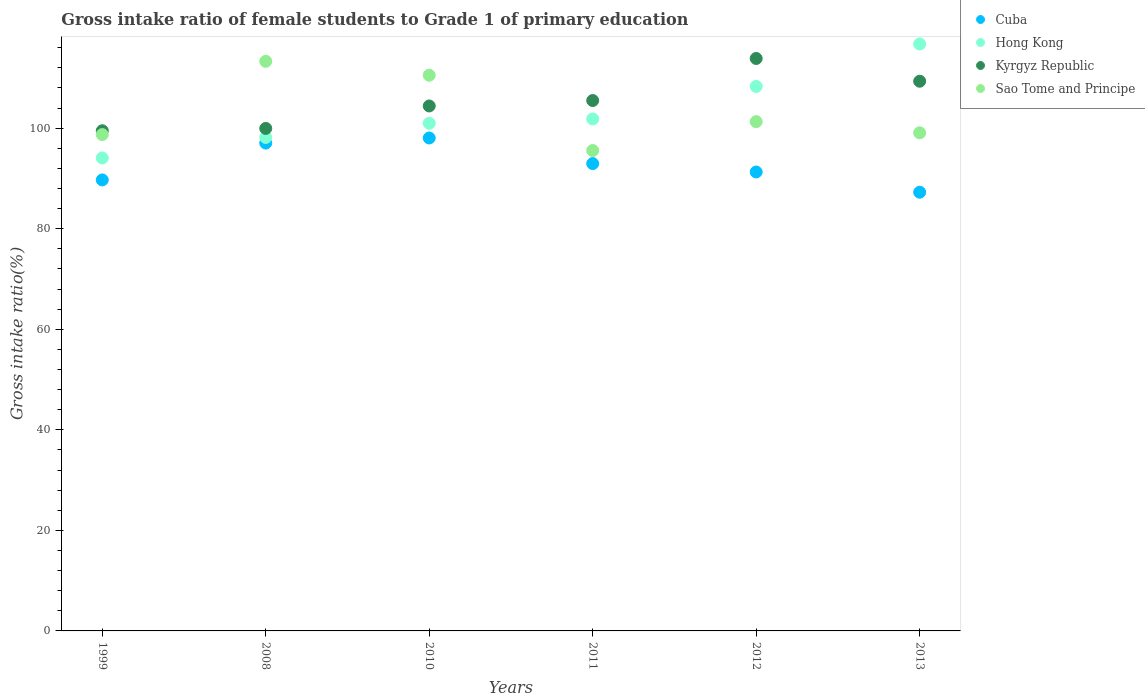How many different coloured dotlines are there?
Make the answer very short. 4. What is the gross intake ratio in Hong Kong in 2010?
Your answer should be very brief. 100.97. Across all years, what is the maximum gross intake ratio in Kyrgyz Republic?
Your response must be concise. 113.86. Across all years, what is the minimum gross intake ratio in Sao Tome and Principe?
Ensure brevity in your answer.  95.55. In which year was the gross intake ratio in Cuba maximum?
Your answer should be very brief. 2010. What is the total gross intake ratio in Kyrgyz Republic in the graph?
Your response must be concise. 632.54. What is the difference between the gross intake ratio in Kyrgyz Republic in 2010 and that in 2011?
Your response must be concise. -1.08. What is the difference between the gross intake ratio in Hong Kong in 2013 and the gross intake ratio in Kyrgyz Republic in 2008?
Offer a very short reply. 16.8. What is the average gross intake ratio in Sao Tome and Principe per year?
Make the answer very short. 103.08. In the year 1999, what is the difference between the gross intake ratio in Hong Kong and gross intake ratio in Sao Tome and Principe?
Make the answer very short. -4.66. In how many years, is the gross intake ratio in Cuba greater than 44 %?
Provide a short and direct response. 6. What is the ratio of the gross intake ratio in Hong Kong in 1999 to that in 2010?
Offer a terse response. 0.93. Is the difference between the gross intake ratio in Hong Kong in 2011 and 2012 greater than the difference between the gross intake ratio in Sao Tome and Principe in 2011 and 2012?
Your answer should be very brief. No. What is the difference between the highest and the second highest gross intake ratio in Sao Tome and Principe?
Provide a short and direct response. 2.77. What is the difference between the highest and the lowest gross intake ratio in Sao Tome and Principe?
Give a very brief answer. 17.74. Is the sum of the gross intake ratio in Hong Kong in 1999 and 2008 greater than the maximum gross intake ratio in Sao Tome and Principe across all years?
Make the answer very short. Yes. Does the gross intake ratio in Hong Kong monotonically increase over the years?
Ensure brevity in your answer.  Yes. How many dotlines are there?
Make the answer very short. 4. Are the values on the major ticks of Y-axis written in scientific E-notation?
Make the answer very short. No. Does the graph contain grids?
Offer a very short reply. No. How are the legend labels stacked?
Your answer should be very brief. Vertical. What is the title of the graph?
Your response must be concise. Gross intake ratio of female students to Grade 1 of primary education. What is the label or title of the X-axis?
Keep it short and to the point. Years. What is the label or title of the Y-axis?
Your response must be concise. Gross intake ratio(%). What is the Gross intake ratio(%) of Cuba in 1999?
Ensure brevity in your answer.  89.7. What is the Gross intake ratio(%) in Hong Kong in 1999?
Offer a terse response. 94.07. What is the Gross intake ratio(%) of Kyrgyz Republic in 1999?
Give a very brief answer. 99.49. What is the Gross intake ratio(%) of Sao Tome and Principe in 1999?
Make the answer very short. 98.73. What is the Gross intake ratio(%) of Cuba in 2008?
Provide a succinct answer. 97.04. What is the Gross intake ratio(%) in Hong Kong in 2008?
Give a very brief answer. 98.15. What is the Gross intake ratio(%) of Kyrgyz Republic in 2008?
Offer a terse response. 99.95. What is the Gross intake ratio(%) of Sao Tome and Principe in 2008?
Offer a very short reply. 113.29. What is the Gross intake ratio(%) in Cuba in 2010?
Your answer should be compact. 98.05. What is the Gross intake ratio(%) in Hong Kong in 2010?
Your answer should be very brief. 100.97. What is the Gross intake ratio(%) in Kyrgyz Republic in 2010?
Make the answer very short. 104.41. What is the Gross intake ratio(%) in Sao Tome and Principe in 2010?
Your response must be concise. 110.52. What is the Gross intake ratio(%) of Cuba in 2011?
Offer a very short reply. 92.95. What is the Gross intake ratio(%) of Hong Kong in 2011?
Offer a very short reply. 101.83. What is the Gross intake ratio(%) in Kyrgyz Republic in 2011?
Offer a terse response. 105.5. What is the Gross intake ratio(%) of Sao Tome and Principe in 2011?
Your response must be concise. 95.55. What is the Gross intake ratio(%) in Cuba in 2012?
Ensure brevity in your answer.  91.28. What is the Gross intake ratio(%) in Hong Kong in 2012?
Your answer should be very brief. 108.3. What is the Gross intake ratio(%) in Kyrgyz Republic in 2012?
Make the answer very short. 113.86. What is the Gross intake ratio(%) in Sao Tome and Principe in 2012?
Your response must be concise. 101.3. What is the Gross intake ratio(%) in Cuba in 2013?
Provide a short and direct response. 87.26. What is the Gross intake ratio(%) in Hong Kong in 2013?
Keep it short and to the point. 116.74. What is the Gross intake ratio(%) of Kyrgyz Republic in 2013?
Your answer should be very brief. 109.34. What is the Gross intake ratio(%) of Sao Tome and Principe in 2013?
Your answer should be compact. 99.08. Across all years, what is the maximum Gross intake ratio(%) in Cuba?
Your answer should be very brief. 98.05. Across all years, what is the maximum Gross intake ratio(%) of Hong Kong?
Offer a very short reply. 116.74. Across all years, what is the maximum Gross intake ratio(%) of Kyrgyz Republic?
Ensure brevity in your answer.  113.86. Across all years, what is the maximum Gross intake ratio(%) of Sao Tome and Principe?
Your answer should be compact. 113.29. Across all years, what is the minimum Gross intake ratio(%) in Cuba?
Your answer should be very brief. 87.26. Across all years, what is the minimum Gross intake ratio(%) of Hong Kong?
Make the answer very short. 94.07. Across all years, what is the minimum Gross intake ratio(%) of Kyrgyz Republic?
Keep it short and to the point. 99.49. Across all years, what is the minimum Gross intake ratio(%) in Sao Tome and Principe?
Ensure brevity in your answer.  95.55. What is the total Gross intake ratio(%) of Cuba in the graph?
Keep it short and to the point. 556.29. What is the total Gross intake ratio(%) in Hong Kong in the graph?
Your response must be concise. 620.07. What is the total Gross intake ratio(%) in Kyrgyz Republic in the graph?
Give a very brief answer. 632.54. What is the total Gross intake ratio(%) in Sao Tome and Principe in the graph?
Your response must be concise. 618.48. What is the difference between the Gross intake ratio(%) in Cuba in 1999 and that in 2008?
Make the answer very short. -7.33. What is the difference between the Gross intake ratio(%) of Hong Kong in 1999 and that in 2008?
Give a very brief answer. -4.08. What is the difference between the Gross intake ratio(%) of Kyrgyz Republic in 1999 and that in 2008?
Offer a terse response. -0.46. What is the difference between the Gross intake ratio(%) of Sao Tome and Principe in 1999 and that in 2008?
Offer a very short reply. -14.57. What is the difference between the Gross intake ratio(%) in Cuba in 1999 and that in 2010?
Provide a short and direct response. -8.35. What is the difference between the Gross intake ratio(%) in Hong Kong in 1999 and that in 2010?
Offer a terse response. -6.9. What is the difference between the Gross intake ratio(%) in Kyrgyz Republic in 1999 and that in 2010?
Give a very brief answer. -4.93. What is the difference between the Gross intake ratio(%) of Sao Tome and Principe in 1999 and that in 2010?
Your response must be concise. -11.8. What is the difference between the Gross intake ratio(%) in Cuba in 1999 and that in 2011?
Give a very brief answer. -3.25. What is the difference between the Gross intake ratio(%) in Hong Kong in 1999 and that in 2011?
Provide a short and direct response. -7.76. What is the difference between the Gross intake ratio(%) of Kyrgyz Republic in 1999 and that in 2011?
Provide a succinct answer. -6.01. What is the difference between the Gross intake ratio(%) of Sao Tome and Principe in 1999 and that in 2011?
Provide a short and direct response. 3.17. What is the difference between the Gross intake ratio(%) in Cuba in 1999 and that in 2012?
Offer a very short reply. -1.58. What is the difference between the Gross intake ratio(%) in Hong Kong in 1999 and that in 2012?
Your answer should be very brief. -14.23. What is the difference between the Gross intake ratio(%) of Kyrgyz Republic in 1999 and that in 2012?
Provide a short and direct response. -14.38. What is the difference between the Gross intake ratio(%) in Sao Tome and Principe in 1999 and that in 2012?
Keep it short and to the point. -2.57. What is the difference between the Gross intake ratio(%) of Cuba in 1999 and that in 2013?
Make the answer very short. 2.44. What is the difference between the Gross intake ratio(%) in Hong Kong in 1999 and that in 2013?
Keep it short and to the point. -22.67. What is the difference between the Gross intake ratio(%) in Kyrgyz Republic in 1999 and that in 2013?
Keep it short and to the point. -9.85. What is the difference between the Gross intake ratio(%) in Sao Tome and Principe in 1999 and that in 2013?
Provide a short and direct response. -0.35. What is the difference between the Gross intake ratio(%) of Cuba in 2008 and that in 2010?
Provide a succinct answer. -1.01. What is the difference between the Gross intake ratio(%) in Hong Kong in 2008 and that in 2010?
Your response must be concise. -2.82. What is the difference between the Gross intake ratio(%) in Kyrgyz Republic in 2008 and that in 2010?
Offer a terse response. -4.47. What is the difference between the Gross intake ratio(%) of Sao Tome and Principe in 2008 and that in 2010?
Provide a short and direct response. 2.77. What is the difference between the Gross intake ratio(%) in Cuba in 2008 and that in 2011?
Offer a very short reply. 4.08. What is the difference between the Gross intake ratio(%) of Hong Kong in 2008 and that in 2011?
Make the answer very short. -3.68. What is the difference between the Gross intake ratio(%) of Kyrgyz Republic in 2008 and that in 2011?
Ensure brevity in your answer.  -5.55. What is the difference between the Gross intake ratio(%) in Sao Tome and Principe in 2008 and that in 2011?
Ensure brevity in your answer.  17.74. What is the difference between the Gross intake ratio(%) in Cuba in 2008 and that in 2012?
Keep it short and to the point. 5.75. What is the difference between the Gross intake ratio(%) of Hong Kong in 2008 and that in 2012?
Offer a very short reply. -10.15. What is the difference between the Gross intake ratio(%) in Kyrgyz Republic in 2008 and that in 2012?
Your response must be concise. -13.91. What is the difference between the Gross intake ratio(%) in Sao Tome and Principe in 2008 and that in 2012?
Keep it short and to the point. 12. What is the difference between the Gross intake ratio(%) of Cuba in 2008 and that in 2013?
Your response must be concise. 9.78. What is the difference between the Gross intake ratio(%) of Hong Kong in 2008 and that in 2013?
Your answer should be very brief. -18.59. What is the difference between the Gross intake ratio(%) of Kyrgyz Republic in 2008 and that in 2013?
Keep it short and to the point. -9.39. What is the difference between the Gross intake ratio(%) of Sao Tome and Principe in 2008 and that in 2013?
Offer a terse response. 14.22. What is the difference between the Gross intake ratio(%) in Cuba in 2010 and that in 2011?
Make the answer very short. 5.1. What is the difference between the Gross intake ratio(%) of Hong Kong in 2010 and that in 2011?
Provide a short and direct response. -0.87. What is the difference between the Gross intake ratio(%) of Kyrgyz Republic in 2010 and that in 2011?
Your answer should be compact. -1.08. What is the difference between the Gross intake ratio(%) of Sao Tome and Principe in 2010 and that in 2011?
Your response must be concise. 14.97. What is the difference between the Gross intake ratio(%) in Cuba in 2010 and that in 2012?
Your answer should be very brief. 6.77. What is the difference between the Gross intake ratio(%) of Hong Kong in 2010 and that in 2012?
Your answer should be very brief. -7.34. What is the difference between the Gross intake ratio(%) in Kyrgyz Republic in 2010 and that in 2012?
Make the answer very short. -9.45. What is the difference between the Gross intake ratio(%) of Sao Tome and Principe in 2010 and that in 2012?
Provide a short and direct response. 9.23. What is the difference between the Gross intake ratio(%) of Cuba in 2010 and that in 2013?
Keep it short and to the point. 10.79. What is the difference between the Gross intake ratio(%) of Hong Kong in 2010 and that in 2013?
Your response must be concise. -15.78. What is the difference between the Gross intake ratio(%) of Kyrgyz Republic in 2010 and that in 2013?
Keep it short and to the point. -4.92. What is the difference between the Gross intake ratio(%) of Sao Tome and Principe in 2010 and that in 2013?
Your answer should be compact. 11.44. What is the difference between the Gross intake ratio(%) of Cuba in 2011 and that in 2012?
Your answer should be compact. 1.67. What is the difference between the Gross intake ratio(%) in Hong Kong in 2011 and that in 2012?
Offer a terse response. -6.47. What is the difference between the Gross intake ratio(%) in Kyrgyz Republic in 2011 and that in 2012?
Offer a terse response. -8.36. What is the difference between the Gross intake ratio(%) in Sao Tome and Principe in 2011 and that in 2012?
Your answer should be very brief. -5.74. What is the difference between the Gross intake ratio(%) in Cuba in 2011 and that in 2013?
Your answer should be compact. 5.7. What is the difference between the Gross intake ratio(%) in Hong Kong in 2011 and that in 2013?
Your answer should be very brief. -14.91. What is the difference between the Gross intake ratio(%) in Kyrgyz Republic in 2011 and that in 2013?
Keep it short and to the point. -3.84. What is the difference between the Gross intake ratio(%) of Sao Tome and Principe in 2011 and that in 2013?
Provide a short and direct response. -3.53. What is the difference between the Gross intake ratio(%) of Cuba in 2012 and that in 2013?
Provide a short and direct response. 4.03. What is the difference between the Gross intake ratio(%) in Hong Kong in 2012 and that in 2013?
Ensure brevity in your answer.  -8.44. What is the difference between the Gross intake ratio(%) of Kyrgyz Republic in 2012 and that in 2013?
Offer a very short reply. 4.52. What is the difference between the Gross intake ratio(%) in Sao Tome and Principe in 2012 and that in 2013?
Provide a succinct answer. 2.22. What is the difference between the Gross intake ratio(%) of Cuba in 1999 and the Gross intake ratio(%) of Hong Kong in 2008?
Provide a succinct answer. -8.45. What is the difference between the Gross intake ratio(%) of Cuba in 1999 and the Gross intake ratio(%) of Kyrgyz Republic in 2008?
Your answer should be very brief. -10.24. What is the difference between the Gross intake ratio(%) of Cuba in 1999 and the Gross intake ratio(%) of Sao Tome and Principe in 2008?
Provide a succinct answer. -23.59. What is the difference between the Gross intake ratio(%) of Hong Kong in 1999 and the Gross intake ratio(%) of Kyrgyz Republic in 2008?
Your response must be concise. -5.88. What is the difference between the Gross intake ratio(%) in Hong Kong in 1999 and the Gross intake ratio(%) in Sao Tome and Principe in 2008?
Your answer should be very brief. -19.22. What is the difference between the Gross intake ratio(%) in Kyrgyz Republic in 1999 and the Gross intake ratio(%) in Sao Tome and Principe in 2008?
Keep it short and to the point. -13.81. What is the difference between the Gross intake ratio(%) in Cuba in 1999 and the Gross intake ratio(%) in Hong Kong in 2010?
Your response must be concise. -11.26. What is the difference between the Gross intake ratio(%) of Cuba in 1999 and the Gross intake ratio(%) of Kyrgyz Republic in 2010?
Provide a short and direct response. -14.71. What is the difference between the Gross intake ratio(%) of Cuba in 1999 and the Gross intake ratio(%) of Sao Tome and Principe in 2010?
Give a very brief answer. -20.82. What is the difference between the Gross intake ratio(%) of Hong Kong in 1999 and the Gross intake ratio(%) of Kyrgyz Republic in 2010?
Offer a terse response. -10.34. What is the difference between the Gross intake ratio(%) of Hong Kong in 1999 and the Gross intake ratio(%) of Sao Tome and Principe in 2010?
Give a very brief answer. -16.45. What is the difference between the Gross intake ratio(%) in Kyrgyz Republic in 1999 and the Gross intake ratio(%) in Sao Tome and Principe in 2010?
Offer a terse response. -11.04. What is the difference between the Gross intake ratio(%) in Cuba in 1999 and the Gross intake ratio(%) in Hong Kong in 2011?
Offer a very short reply. -12.13. What is the difference between the Gross intake ratio(%) of Cuba in 1999 and the Gross intake ratio(%) of Kyrgyz Republic in 2011?
Provide a succinct answer. -15.79. What is the difference between the Gross intake ratio(%) in Cuba in 1999 and the Gross intake ratio(%) in Sao Tome and Principe in 2011?
Your response must be concise. -5.85. What is the difference between the Gross intake ratio(%) in Hong Kong in 1999 and the Gross intake ratio(%) in Kyrgyz Republic in 2011?
Your answer should be compact. -11.43. What is the difference between the Gross intake ratio(%) of Hong Kong in 1999 and the Gross intake ratio(%) of Sao Tome and Principe in 2011?
Your answer should be very brief. -1.48. What is the difference between the Gross intake ratio(%) in Kyrgyz Republic in 1999 and the Gross intake ratio(%) in Sao Tome and Principe in 2011?
Keep it short and to the point. 3.93. What is the difference between the Gross intake ratio(%) of Cuba in 1999 and the Gross intake ratio(%) of Hong Kong in 2012?
Your response must be concise. -18.6. What is the difference between the Gross intake ratio(%) in Cuba in 1999 and the Gross intake ratio(%) in Kyrgyz Republic in 2012?
Make the answer very short. -24.16. What is the difference between the Gross intake ratio(%) of Cuba in 1999 and the Gross intake ratio(%) of Sao Tome and Principe in 2012?
Ensure brevity in your answer.  -11.59. What is the difference between the Gross intake ratio(%) of Hong Kong in 1999 and the Gross intake ratio(%) of Kyrgyz Republic in 2012?
Your answer should be very brief. -19.79. What is the difference between the Gross intake ratio(%) in Hong Kong in 1999 and the Gross intake ratio(%) in Sao Tome and Principe in 2012?
Your answer should be very brief. -7.23. What is the difference between the Gross intake ratio(%) of Kyrgyz Republic in 1999 and the Gross intake ratio(%) of Sao Tome and Principe in 2012?
Your answer should be very brief. -1.81. What is the difference between the Gross intake ratio(%) of Cuba in 1999 and the Gross intake ratio(%) of Hong Kong in 2013?
Offer a terse response. -27.04. What is the difference between the Gross intake ratio(%) in Cuba in 1999 and the Gross intake ratio(%) in Kyrgyz Republic in 2013?
Make the answer very short. -19.63. What is the difference between the Gross intake ratio(%) in Cuba in 1999 and the Gross intake ratio(%) in Sao Tome and Principe in 2013?
Ensure brevity in your answer.  -9.38. What is the difference between the Gross intake ratio(%) in Hong Kong in 1999 and the Gross intake ratio(%) in Kyrgyz Republic in 2013?
Make the answer very short. -15.27. What is the difference between the Gross intake ratio(%) in Hong Kong in 1999 and the Gross intake ratio(%) in Sao Tome and Principe in 2013?
Make the answer very short. -5.01. What is the difference between the Gross intake ratio(%) of Kyrgyz Republic in 1999 and the Gross intake ratio(%) of Sao Tome and Principe in 2013?
Provide a succinct answer. 0.41. What is the difference between the Gross intake ratio(%) of Cuba in 2008 and the Gross intake ratio(%) of Hong Kong in 2010?
Provide a short and direct response. -3.93. What is the difference between the Gross intake ratio(%) of Cuba in 2008 and the Gross intake ratio(%) of Kyrgyz Republic in 2010?
Your response must be concise. -7.38. What is the difference between the Gross intake ratio(%) in Cuba in 2008 and the Gross intake ratio(%) in Sao Tome and Principe in 2010?
Ensure brevity in your answer.  -13.49. What is the difference between the Gross intake ratio(%) of Hong Kong in 2008 and the Gross intake ratio(%) of Kyrgyz Republic in 2010?
Offer a terse response. -6.26. What is the difference between the Gross intake ratio(%) in Hong Kong in 2008 and the Gross intake ratio(%) in Sao Tome and Principe in 2010?
Make the answer very short. -12.37. What is the difference between the Gross intake ratio(%) in Kyrgyz Republic in 2008 and the Gross intake ratio(%) in Sao Tome and Principe in 2010?
Offer a terse response. -10.58. What is the difference between the Gross intake ratio(%) of Cuba in 2008 and the Gross intake ratio(%) of Hong Kong in 2011?
Your answer should be very brief. -4.8. What is the difference between the Gross intake ratio(%) in Cuba in 2008 and the Gross intake ratio(%) in Kyrgyz Republic in 2011?
Your answer should be compact. -8.46. What is the difference between the Gross intake ratio(%) in Cuba in 2008 and the Gross intake ratio(%) in Sao Tome and Principe in 2011?
Provide a succinct answer. 1.48. What is the difference between the Gross intake ratio(%) in Hong Kong in 2008 and the Gross intake ratio(%) in Kyrgyz Republic in 2011?
Your answer should be very brief. -7.35. What is the difference between the Gross intake ratio(%) in Hong Kong in 2008 and the Gross intake ratio(%) in Sao Tome and Principe in 2011?
Make the answer very short. 2.6. What is the difference between the Gross intake ratio(%) of Kyrgyz Republic in 2008 and the Gross intake ratio(%) of Sao Tome and Principe in 2011?
Your answer should be very brief. 4.39. What is the difference between the Gross intake ratio(%) of Cuba in 2008 and the Gross intake ratio(%) of Hong Kong in 2012?
Your answer should be very brief. -11.27. What is the difference between the Gross intake ratio(%) in Cuba in 2008 and the Gross intake ratio(%) in Kyrgyz Republic in 2012?
Make the answer very short. -16.83. What is the difference between the Gross intake ratio(%) of Cuba in 2008 and the Gross intake ratio(%) of Sao Tome and Principe in 2012?
Ensure brevity in your answer.  -4.26. What is the difference between the Gross intake ratio(%) of Hong Kong in 2008 and the Gross intake ratio(%) of Kyrgyz Republic in 2012?
Ensure brevity in your answer.  -15.71. What is the difference between the Gross intake ratio(%) of Hong Kong in 2008 and the Gross intake ratio(%) of Sao Tome and Principe in 2012?
Offer a terse response. -3.15. What is the difference between the Gross intake ratio(%) of Kyrgyz Republic in 2008 and the Gross intake ratio(%) of Sao Tome and Principe in 2012?
Provide a short and direct response. -1.35. What is the difference between the Gross intake ratio(%) of Cuba in 2008 and the Gross intake ratio(%) of Hong Kong in 2013?
Your answer should be very brief. -19.71. What is the difference between the Gross intake ratio(%) in Cuba in 2008 and the Gross intake ratio(%) in Kyrgyz Republic in 2013?
Offer a terse response. -12.3. What is the difference between the Gross intake ratio(%) of Cuba in 2008 and the Gross intake ratio(%) of Sao Tome and Principe in 2013?
Your response must be concise. -2.04. What is the difference between the Gross intake ratio(%) of Hong Kong in 2008 and the Gross intake ratio(%) of Kyrgyz Republic in 2013?
Give a very brief answer. -11.19. What is the difference between the Gross intake ratio(%) of Hong Kong in 2008 and the Gross intake ratio(%) of Sao Tome and Principe in 2013?
Offer a very short reply. -0.93. What is the difference between the Gross intake ratio(%) of Kyrgyz Republic in 2008 and the Gross intake ratio(%) of Sao Tome and Principe in 2013?
Provide a succinct answer. 0.87. What is the difference between the Gross intake ratio(%) in Cuba in 2010 and the Gross intake ratio(%) in Hong Kong in 2011?
Offer a very short reply. -3.78. What is the difference between the Gross intake ratio(%) of Cuba in 2010 and the Gross intake ratio(%) of Kyrgyz Republic in 2011?
Keep it short and to the point. -7.45. What is the difference between the Gross intake ratio(%) of Cuba in 2010 and the Gross intake ratio(%) of Sao Tome and Principe in 2011?
Provide a short and direct response. 2.5. What is the difference between the Gross intake ratio(%) in Hong Kong in 2010 and the Gross intake ratio(%) in Kyrgyz Republic in 2011?
Give a very brief answer. -4.53. What is the difference between the Gross intake ratio(%) in Hong Kong in 2010 and the Gross intake ratio(%) in Sao Tome and Principe in 2011?
Keep it short and to the point. 5.41. What is the difference between the Gross intake ratio(%) of Kyrgyz Republic in 2010 and the Gross intake ratio(%) of Sao Tome and Principe in 2011?
Your answer should be very brief. 8.86. What is the difference between the Gross intake ratio(%) in Cuba in 2010 and the Gross intake ratio(%) in Hong Kong in 2012?
Make the answer very short. -10.25. What is the difference between the Gross intake ratio(%) of Cuba in 2010 and the Gross intake ratio(%) of Kyrgyz Republic in 2012?
Keep it short and to the point. -15.81. What is the difference between the Gross intake ratio(%) in Cuba in 2010 and the Gross intake ratio(%) in Sao Tome and Principe in 2012?
Provide a short and direct response. -3.25. What is the difference between the Gross intake ratio(%) in Hong Kong in 2010 and the Gross intake ratio(%) in Kyrgyz Republic in 2012?
Keep it short and to the point. -12.89. What is the difference between the Gross intake ratio(%) in Hong Kong in 2010 and the Gross intake ratio(%) in Sao Tome and Principe in 2012?
Provide a short and direct response. -0.33. What is the difference between the Gross intake ratio(%) of Kyrgyz Republic in 2010 and the Gross intake ratio(%) of Sao Tome and Principe in 2012?
Provide a succinct answer. 3.12. What is the difference between the Gross intake ratio(%) in Cuba in 2010 and the Gross intake ratio(%) in Hong Kong in 2013?
Give a very brief answer. -18.69. What is the difference between the Gross intake ratio(%) in Cuba in 2010 and the Gross intake ratio(%) in Kyrgyz Republic in 2013?
Your response must be concise. -11.29. What is the difference between the Gross intake ratio(%) in Cuba in 2010 and the Gross intake ratio(%) in Sao Tome and Principe in 2013?
Provide a succinct answer. -1.03. What is the difference between the Gross intake ratio(%) in Hong Kong in 2010 and the Gross intake ratio(%) in Kyrgyz Republic in 2013?
Offer a very short reply. -8.37. What is the difference between the Gross intake ratio(%) in Hong Kong in 2010 and the Gross intake ratio(%) in Sao Tome and Principe in 2013?
Keep it short and to the point. 1.89. What is the difference between the Gross intake ratio(%) of Kyrgyz Republic in 2010 and the Gross intake ratio(%) of Sao Tome and Principe in 2013?
Offer a terse response. 5.34. What is the difference between the Gross intake ratio(%) in Cuba in 2011 and the Gross intake ratio(%) in Hong Kong in 2012?
Provide a succinct answer. -15.35. What is the difference between the Gross intake ratio(%) of Cuba in 2011 and the Gross intake ratio(%) of Kyrgyz Republic in 2012?
Your response must be concise. -20.91. What is the difference between the Gross intake ratio(%) of Cuba in 2011 and the Gross intake ratio(%) of Sao Tome and Principe in 2012?
Give a very brief answer. -8.34. What is the difference between the Gross intake ratio(%) of Hong Kong in 2011 and the Gross intake ratio(%) of Kyrgyz Republic in 2012?
Offer a very short reply. -12.03. What is the difference between the Gross intake ratio(%) of Hong Kong in 2011 and the Gross intake ratio(%) of Sao Tome and Principe in 2012?
Your answer should be very brief. 0.54. What is the difference between the Gross intake ratio(%) in Kyrgyz Republic in 2011 and the Gross intake ratio(%) in Sao Tome and Principe in 2012?
Offer a terse response. 4.2. What is the difference between the Gross intake ratio(%) of Cuba in 2011 and the Gross intake ratio(%) of Hong Kong in 2013?
Offer a very short reply. -23.79. What is the difference between the Gross intake ratio(%) of Cuba in 2011 and the Gross intake ratio(%) of Kyrgyz Republic in 2013?
Provide a succinct answer. -16.38. What is the difference between the Gross intake ratio(%) in Cuba in 2011 and the Gross intake ratio(%) in Sao Tome and Principe in 2013?
Offer a very short reply. -6.12. What is the difference between the Gross intake ratio(%) of Hong Kong in 2011 and the Gross intake ratio(%) of Kyrgyz Republic in 2013?
Your answer should be compact. -7.5. What is the difference between the Gross intake ratio(%) in Hong Kong in 2011 and the Gross intake ratio(%) in Sao Tome and Principe in 2013?
Your answer should be compact. 2.76. What is the difference between the Gross intake ratio(%) of Kyrgyz Republic in 2011 and the Gross intake ratio(%) of Sao Tome and Principe in 2013?
Provide a short and direct response. 6.42. What is the difference between the Gross intake ratio(%) of Cuba in 2012 and the Gross intake ratio(%) of Hong Kong in 2013?
Provide a short and direct response. -25.46. What is the difference between the Gross intake ratio(%) in Cuba in 2012 and the Gross intake ratio(%) in Kyrgyz Republic in 2013?
Offer a terse response. -18.05. What is the difference between the Gross intake ratio(%) in Cuba in 2012 and the Gross intake ratio(%) in Sao Tome and Principe in 2013?
Keep it short and to the point. -7.79. What is the difference between the Gross intake ratio(%) in Hong Kong in 2012 and the Gross intake ratio(%) in Kyrgyz Republic in 2013?
Ensure brevity in your answer.  -1.03. What is the difference between the Gross intake ratio(%) of Hong Kong in 2012 and the Gross intake ratio(%) of Sao Tome and Principe in 2013?
Keep it short and to the point. 9.22. What is the difference between the Gross intake ratio(%) of Kyrgyz Republic in 2012 and the Gross intake ratio(%) of Sao Tome and Principe in 2013?
Your answer should be compact. 14.78. What is the average Gross intake ratio(%) in Cuba per year?
Your answer should be compact. 92.71. What is the average Gross intake ratio(%) of Hong Kong per year?
Offer a very short reply. 103.34. What is the average Gross intake ratio(%) of Kyrgyz Republic per year?
Provide a succinct answer. 105.42. What is the average Gross intake ratio(%) in Sao Tome and Principe per year?
Offer a very short reply. 103.08. In the year 1999, what is the difference between the Gross intake ratio(%) in Cuba and Gross intake ratio(%) in Hong Kong?
Your answer should be compact. -4.37. In the year 1999, what is the difference between the Gross intake ratio(%) of Cuba and Gross intake ratio(%) of Kyrgyz Republic?
Ensure brevity in your answer.  -9.78. In the year 1999, what is the difference between the Gross intake ratio(%) of Cuba and Gross intake ratio(%) of Sao Tome and Principe?
Your answer should be compact. -9.02. In the year 1999, what is the difference between the Gross intake ratio(%) of Hong Kong and Gross intake ratio(%) of Kyrgyz Republic?
Your answer should be compact. -5.42. In the year 1999, what is the difference between the Gross intake ratio(%) of Hong Kong and Gross intake ratio(%) of Sao Tome and Principe?
Your answer should be compact. -4.66. In the year 1999, what is the difference between the Gross intake ratio(%) in Kyrgyz Republic and Gross intake ratio(%) in Sao Tome and Principe?
Provide a short and direct response. 0.76. In the year 2008, what is the difference between the Gross intake ratio(%) of Cuba and Gross intake ratio(%) of Hong Kong?
Keep it short and to the point. -1.12. In the year 2008, what is the difference between the Gross intake ratio(%) in Cuba and Gross intake ratio(%) in Kyrgyz Republic?
Your answer should be very brief. -2.91. In the year 2008, what is the difference between the Gross intake ratio(%) in Cuba and Gross intake ratio(%) in Sao Tome and Principe?
Offer a terse response. -16.26. In the year 2008, what is the difference between the Gross intake ratio(%) of Hong Kong and Gross intake ratio(%) of Kyrgyz Republic?
Offer a very short reply. -1.8. In the year 2008, what is the difference between the Gross intake ratio(%) of Hong Kong and Gross intake ratio(%) of Sao Tome and Principe?
Your answer should be very brief. -15.14. In the year 2008, what is the difference between the Gross intake ratio(%) in Kyrgyz Republic and Gross intake ratio(%) in Sao Tome and Principe?
Offer a very short reply. -13.35. In the year 2010, what is the difference between the Gross intake ratio(%) in Cuba and Gross intake ratio(%) in Hong Kong?
Offer a terse response. -2.92. In the year 2010, what is the difference between the Gross intake ratio(%) in Cuba and Gross intake ratio(%) in Kyrgyz Republic?
Keep it short and to the point. -6.36. In the year 2010, what is the difference between the Gross intake ratio(%) of Cuba and Gross intake ratio(%) of Sao Tome and Principe?
Your response must be concise. -12.47. In the year 2010, what is the difference between the Gross intake ratio(%) in Hong Kong and Gross intake ratio(%) in Kyrgyz Republic?
Give a very brief answer. -3.45. In the year 2010, what is the difference between the Gross intake ratio(%) of Hong Kong and Gross intake ratio(%) of Sao Tome and Principe?
Provide a succinct answer. -9.56. In the year 2010, what is the difference between the Gross intake ratio(%) in Kyrgyz Republic and Gross intake ratio(%) in Sao Tome and Principe?
Make the answer very short. -6.11. In the year 2011, what is the difference between the Gross intake ratio(%) in Cuba and Gross intake ratio(%) in Hong Kong?
Your answer should be very brief. -8.88. In the year 2011, what is the difference between the Gross intake ratio(%) of Cuba and Gross intake ratio(%) of Kyrgyz Republic?
Ensure brevity in your answer.  -12.54. In the year 2011, what is the difference between the Gross intake ratio(%) of Cuba and Gross intake ratio(%) of Sao Tome and Principe?
Ensure brevity in your answer.  -2.6. In the year 2011, what is the difference between the Gross intake ratio(%) of Hong Kong and Gross intake ratio(%) of Kyrgyz Republic?
Ensure brevity in your answer.  -3.66. In the year 2011, what is the difference between the Gross intake ratio(%) in Hong Kong and Gross intake ratio(%) in Sao Tome and Principe?
Keep it short and to the point. 6.28. In the year 2011, what is the difference between the Gross intake ratio(%) in Kyrgyz Republic and Gross intake ratio(%) in Sao Tome and Principe?
Your answer should be compact. 9.94. In the year 2012, what is the difference between the Gross intake ratio(%) in Cuba and Gross intake ratio(%) in Hong Kong?
Offer a terse response. -17.02. In the year 2012, what is the difference between the Gross intake ratio(%) of Cuba and Gross intake ratio(%) of Kyrgyz Republic?
Give a very brief answer. -22.58. In the year 2012, what is the difference between the Gross intake ratio(%) of Cuba and Gross intake ratio(%) of Sao Tome and Principe?
Give a very brief answer. -10.01. In the year 2012, what is the difference between the Gross intake ratio(%) in Hong Kong and Gross intake ratio(%) in Kyrgyz Republic?
Your answer should be very brief. -5.56. In the year 2012, what is the difference between the Gross intake ratio(%) in Hong Kong and Gross intake ratio(%) in Sao Tome and Principe?
Your response must be concise. 7. In the year 2012, what is the difference between the Gross intake ratio(%) of Kyrgyz Republic and Gross intake ratio(%) of Sao Tome and Principe?
Provide a succinct answer. 12.56. In the year 2013, what is the difference between the Gross intake ratio(%) in Cuba and Gross intake ratio(%) in Hong Kong?
Make the answer very short. -29.48. In the year 2013, what is the difference between the Gross intake ratio(%) in Cuba and Gross intake ratio(%) in Kyrgyz Republic?
Offer a terse response. -22.08. In the year 2013, what is the difference between the Gross intake ratio(%) of Cuba and Gross intake ratio(%) of Sao Tome and Principe?
Offer a very short reply. -11.82. In the year 2013, what is the difference between the Gross intake ratio(%) of Hong Kong and Gross intake ratio(%) of Kyrgyz Republic?
Provide a short and direct response. 7.41. In the year 2013, what is the difference between the Gross intake ratio(%) in Hong Kong and Gross intake ratio(%) in Sao Tome and Principe?
Ensure brevity in your answer.  17.66. In the year 2013, what is the difference between the Gross intake ratio(%) in Kyrgyz Republic and Gross intake ratio(%) in Sao Tome and Principe?
Ensure brevity in your answer.  10.26. What is the ratio of the Gross intake ratio(%) in Cuba in 1999 to that in 2008?
Make the answer very short. 0.92. What is the ratio of the Gross intake ratio(%) in Hong Kong in 1999 to that in 2008?
Keep it short and to the point. 0.96. What is the ratio of the Gross intake ratio(%) in Sao Tome and Principe in 1999 to that in 2008?
Your response must be concise. 0.87. What is the ratio of the Gross intake ratio(%) of Cuba in 1999 to that in 2010?
Offer a very short reply. 0.91. What is the ratio of the Gross intake ratio(%) in Hong Kong in 1999 to that in 2010?
Your answer should be compact. 0.93. What is the ratio of the Gross intake ratio(%) in Kyrgyz Republic in 1999 to that in 2010?
Offer a very short reply. 0.95. What is the ratio of the Gross intake ratio(%) of Sao Tome and Principe in 1999 to that in 2010?
Ensure brevity in your answer.  0.89. What is the ratio of the Gross intake ratio(%) in Hong Kong in 1999 to that in 2011?
Make the answer very short. 0.92. What is the ratio of the Gross intake ratio(%) in Kyrgyz Republic in 1999 to that in 2011?
Ensure brevity in your answer.  0.94. What is the ratio of the Gross intake ratio(%) of Sao Tome and Principe in 1999 to that in 2011?
Your response must be concise. 1.03. What is the ratio of the Gross intake ratio(%) of Cuba in 1999 to that in 2012?
Your answer should be very brief. 0.98. What is the ratio of the Gross intake ratio(%) of Hong Kong in 1999 to that in 2012?
Provide a short and direct response. 0.87. What is the ratio of the Gross intake ratio(%) of Kyrgyz Republic in 1999 to that in 2012?
Make the answer very short. 0.87. What is the ratio of the Gross intake ratio(%) in Sao Tome and Principe in 1999 to that in 2012?
Offer a terse response. 0.97. What is the ratio of the Gross intake ratio(%) of Cuba in 1999 to that in 2013?
Ensure brevity in your answer.  1.03. What is the ratio of the Gross intake ratio(%) of Hong Kong in 1999 to that in 2013?
Offer a very short reply. 0.81. What is the ratio of the Gross intake ratio(%) in Kyrgyz Republic in 1999 to that in 2013?
Keep it short and to the point. 0.91. What is the ratio of the Gross intake ratio(%) in Sao Tome and Principe in 1999 to that in 2013?
Keep it short and to the point. 1. What is the ratio of the Gross intake ratio(%) of Hong Kong in 2008 to that in 2010?
Your response must be concise. 0.97. What is the ratio of the Gross intake ratio(%) of Kyrgyz Republic in 2008 to that in 2010?
Your answer should be compact. 0.96. What is the ratio of the Gross intake ratio(%) of Sao Tome and Principe in 2008 to that in 2010?
Make the answer very short. 1.03. What is the ratio of the Gross intake ratio(%) of Cuba in 2008 to that in 2011?
Keep it short and to the point. 1.04. What is the ratio of the Gross intake ratio(%) of Hong Kong in 2008 to that in 2011?
Offer a very short reply. 0.96. What is the ratio of the Gross intake ratio(%) in Kyrgyz Republic in 2008 to that in 2011?
Make the answer very short. 0.95. What is the ratio of the Gross intake ratio(%) of Sao Tome and Principe in 2008 to that in 2011?
Offer a terse response. 1.19. What is the ratio of the Gross intake ratio(%) in Cuba in 2008 to that in 2012?
Offer a very short reply. 1.06. What is the ratio of the Gross intake ratio(%) in Hong Kong in 2008 to that in 2012?
Provide a succinct answer. 0.91. What is the ratio of the Gross intake ratio(%) of Kyrgyz Republic in 2008 to that in 2012?
Make the answer very short. 0.88. What is the ratio of the Gross intake ratio(%) of Sao Tome and Principe in 2008 to that in 2012?
Your response must be concise. 1.12. What is the ratio of the Gross intake ratio(%) in Cuba in 2008 to that in 2013?
Your answer should be compact. 1.11. What is the ratio of the Gross intake ratio(%) in Hong Kong in 2008 to that in 2013?
Provide a short and direct response. 0.84. What is the ratio of the Gross intake ratio(%) in Kyrgyz Republic in 2008 to that in 2013?
Offer a terse response. 0.91. What is the ratio of the Gross intake ratio(%) in Sao Tome and Principe in 2008 to that in 2013?
Provide a succinct answer. 1.14. What is the ratio of the Gross intake ratio(%) of Cuba in 2010 to that in 2011?
Provide a succinct answer. 1.05. What is the ratio of the Gross intake ratio(%) of Hong Kong in 2010 to that in 2011?
Provide a short and direct response. 0.99. What is the ratio of the Gross intake ratio(%) in Sao Tome and Principe in 2010 to that in 2011?
Your answer should be compact. 1.16. What is the ratio of the Gross intake ratio(%) in Cuba in 2010 to that in 2012?
Your answer should be very brief. 1.07. What is the ratio of the Gross intake ratio(%) of Hong Kong in 2010 to that in 2012?
Make the answer very short. 0.93. What is the ratio of the Gross intake ratio(%) in Kyrgyz Republic in 2010 to that in 2012?
Your answer should be compact. 0.92. What is the ratio of the Gross intake ratio(%) of Sao Tome and Principe in 2010 to that in 2012?
Your response must be concise. 1.09. What is the ratio of the Gross intake ratio(%) in Cuba in 2010 to that in 2013?
Your response must be concise. 1.12. What is the ratio of the Gross intake ratio(%) in Hong Kong in 2010 to that in 2013?
Offer a terse response. 0.86. What is the ratio of the Gross intake ratio(%) of Kyrgyz Republic in 2010 to that in 2013?
Offer a terse response. 0.95. What is the ratio of the Gross intake ratio(%) of Sao Tome and Principe in 2010 to that in 2013?
Provide a short and direct response. 1.12. What is the ratio of the Gross intake ratio(%) in Cuba in 2011 to that in 2012?
Provide a short and direct response. 1.02. What is the ratio of the Gross intake ratio(%) of Hong Kong in 2011 to that in 2012?
Offer a very short reply. 0.94. What is the ratio of the Gross intake ratio(%) of Kyrgyz Republic in 2011 to that in 2012?
Your answer should be very brief. 0.93. What is the ratio of the Gross intake ratio(%) in Sao Tome and Principe in 2011 to that in 2012?
Ensure brevity in your answer.  0.94. What is the ratio of the Gross intake ratio(%) of Cuba in 2011 to that in 2013?
Your answer should be compact. 1.07. What is the ratio of the Gross intake ratio(%) of Hong Kong in 2011 to that in 2013?
Keep it short and to the point. 0.87. What is the ratio of the Gross intake ratio(%) of Kyrgyz Republic in 2011 to that in 2013?
Make the answer very short. 0.96. What is the ratio of the Gross intake ratio(%) of Sao Tome and Principe in 2011 to that in 2013?
Offer a terse response. 0.96. What is the ratio of the Gross intake ratio(%) of Cuba in 2012 to that in 2013?
Offer a terse response. 1.05. What is the ratio of the Gross intake ratio(%) of Hong Kong in 2012 to that in 2013?
Ensure brevity in your answer.  0.93. What is the ratio of the Gross intake ratio(%) in Kyrgyz Republic in 2012 to that in 2013?
Ensure brevity in your answer.  1.04. What is the ratio of the Gross intake ratio(%) in Sao Tome and Principe in 2012 to that in 2013?
Offer a terse response. 1.02. What is the difference between the highest and the second highest Gross intake ratio(%) in Cuba?
Give a very brief answer. 1.01. What is the difference between the highest and the second highest Gross intake ratio(%) in Hong Kong?
Keep it short and to the point. 8.44. What is the difference between the highest and the second highest Gross intake ratio(%) of Kyrgyz Republic?
Offer a very short reply. 4.52. What is the difference between the highest and the second highest Gross intake ratio(%) of Sao Tome and Principe?
Your answer should be compact. 2.77. What is the difference between the highest and the lowest Gross intake ratio(%) in Cuba?
Your answer should be compact. 10.79. What is the difference between the highest and the lowest Gross intake ratio(%) of Hong Kong?
Offer a very short reply. 22.67. What is the difference between the highest and the lowest Gross intake ratio(%) of Kyrgyz Republic?
Provide a short and direct response. 14.38. What is the difference between the highest and the lowest Gross intake ratio(%) in Sao Tome and Principe?
Your response must be concise. 17.74. 